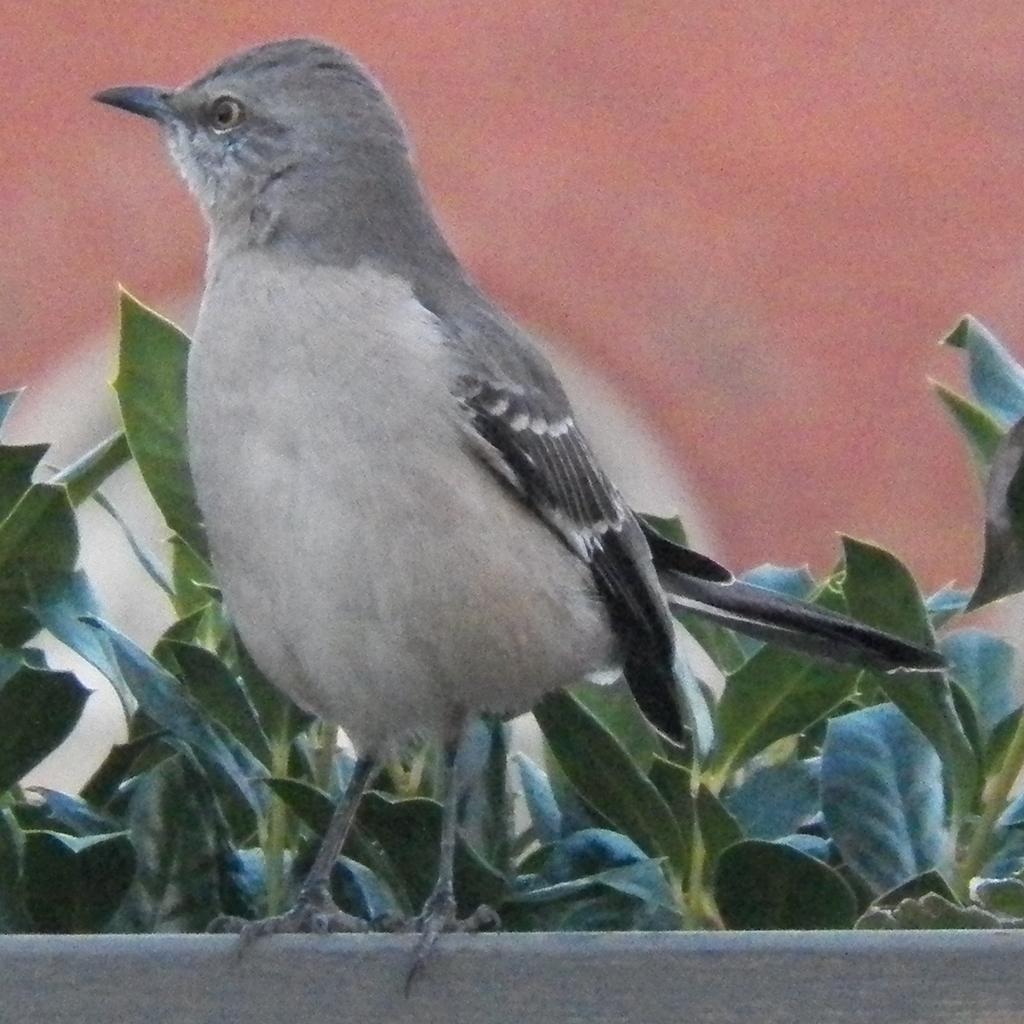What type of animal can be seen in the image? There is a bird in the image. What is the bird standing on? The bird is standing on a pot. What can be seen in the background of the image? There are plants in the background of the image. What type of maid is visible in the image? There is no maid present in the image; it features a bird standing on a pot with plants in the background. 